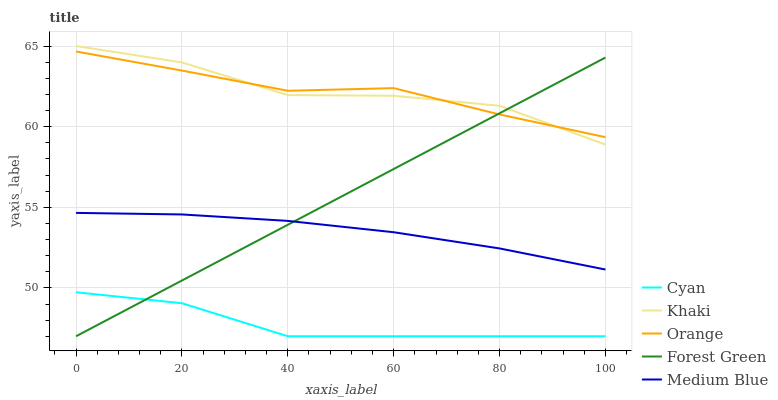Does Cyan have the minimum area under the curve?
Answer yes or no. Yes. Does Khaki have the maximum area under the curve?
Answer yes or no. Yes. Does Forest Green have the minimum area under the curve?
Answer yes or no. No. Does Forest Green have the maximum area under the curve?
Answer yes or no. No. Is Forest Green the smoothest?
Answer yes or no. Yes. Is Khaki the roughest?
Answer yes or no. Yes. Is Cyan the smoothest?
Answer yes or no. No. Is Cyan the roughest?
Answer yes or no. No. Does Cyan have the lowest value?
Answer yes or no. Yes. Does Khaki have the lowest value?
Answer yes or no. No. Does Khaki have the highest value?
Answer yes or no. Yes. Does Forest Green have the highest value?
Answer yes or no. No. Is Medium Blue less than Khaki?
Answer yes or no. Yes. Is Khaki greater than Cyan?
Answer yes or no. Yes. Does Forest Green intersect Khaki?
Answer yes or no. Yes. Is Forest Green less than Khaki?
Answer yes or no. No. Is Forest Green greater than Khaki?
Answer yes or no. No. Does Medium Blue intersect Khaki?
Answer yes or no. No. 